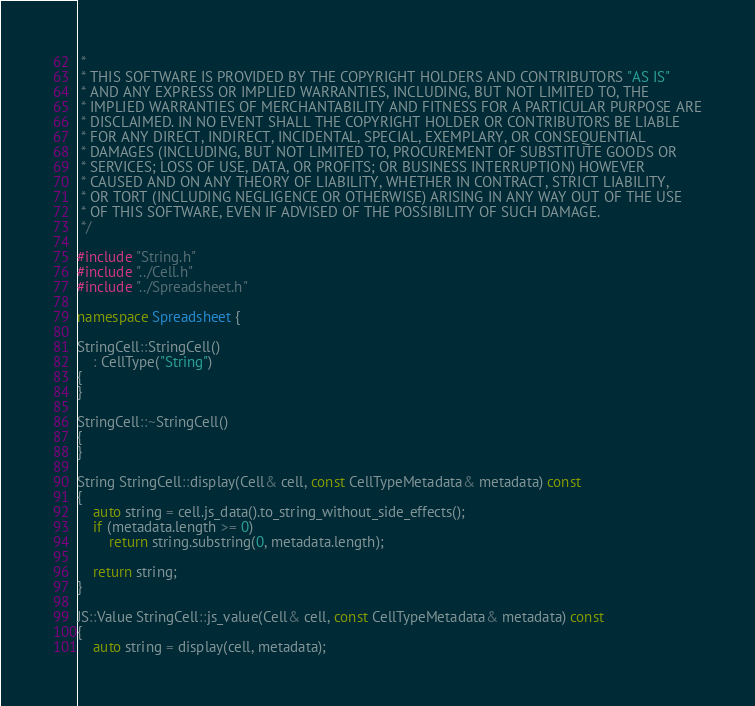Convert code to text. <code><loc_0><loc_0><loc_500><loc_500><_C++_> *
 * THIS SOFTWARE IS PROVIDED BY THE COPYRIGHT HOLDERS AND CONTRIBUTORS "AS IS"
 * AND ANY EXPRESS OR IMPLIED WARRANTIES, INCLUDING, BUT NOT LIMITED TO, THE
 * IMPLIED WARRANTIES OF MERCHANTABILITY AND FITNESS FOR A PARTICULAR PURPOSE ARE
 * DISCLAIMED. IN NO EVENT SHALL THE COPYRIGHT HOLDER OR CONTRIBUTORS BE LIABLE
 * FOR ANY DIRECT, INDIRECT, INCIDENTAL, SPECIAL, EXEMPLARY, OR CONSEQUENTIAL
 * DAMAGES (INCLUDING, BUT NOT LIMITED TO, PROCUREMENT OF SUBSTITUTE GOODS OR
 * SERVICES; LOSS OF USE, DATA, OR PROFITS; OR BUSINESS INTERRUPTION) HOWEVER
 * CAUSED AND ON ANY THEORY OF LIABILITY, WHETHER IN CONTRACT, STRICT LIABILITY,
 * OR TORT (INCLUDING NEGLIGENCE OR OTHERWISE) ARISING IN ANY WAY OUT OF THE USE
 * OF THIS SOFTWARE, EVEN IF ADVISED OF THE POSSIBILITY OF SUCH DAMAGE.
 */

#include "String.h"
#include "../Cell.h"
#include "../Spreadsheet.h"

namespace Spreadsheet {

StringCell::StringCell()
    : CellType("String")
{
}

StringCell::~StringCell()
{
}

String StringCell::display(Cell& cell, const CellTypeMetadata& metadata) const
{
    auto string = cell.js_data().to_string_without_side_effects();
    if (metadata.length >= 0)
        return string.substring(0, metadata.length);

    return string;
}

JS::Value StringCell::js_value(Cell& cell, const CellTypeMetadata& metadata) const
{
    auto string = display(cell, metadata);</code> 